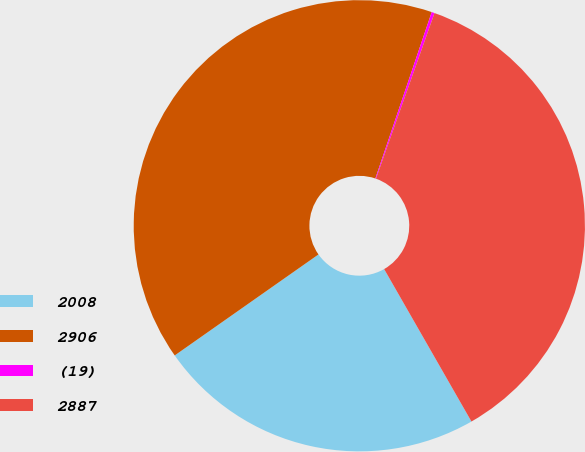Convert chart. <chart><loc_0><loc_0><loc_500><loc_500><pie_chart><fcel>2008<fcel>2906<fcel>(19)<fcel>2887<nl><fcel>23.53%<fcel>39.94%<fcel>0.21%<fcel>36.31%<nl></chart> 